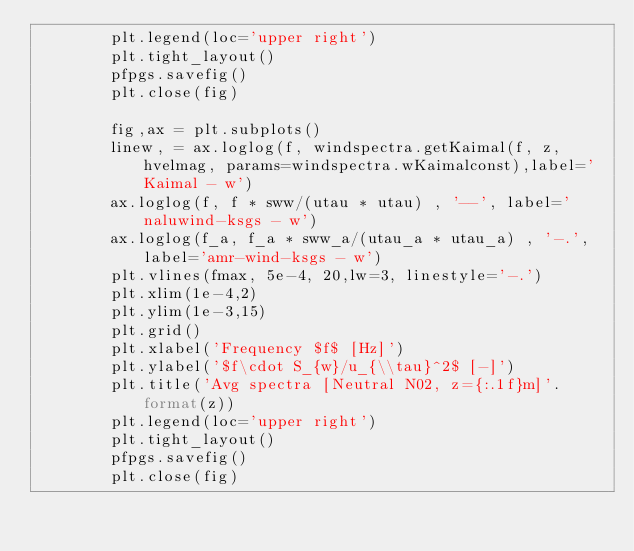<code> <loc_0><loc_0><loc_500><loc_500><_Python_>        plt.legend(loc='upper right')
        plt.tight_layout()
        pfpgs.savefig()
        plt.close(fig)
        
        fig,ax = plt.subplots()
        linew, = ax.loglog(f, windspectra.getKaimal(f, z, hvelmag, params=windspectra.wKaimalconst),label='Kaimal - w')
        ax.loglog(f, f * sww/(utau * utau) , '--', label='naluwind-ksgs - w')
        ax.loglog(f_a, f_a * sww_a/(utau_a * utau_a) , '-.', label='amr-wind-ksgs - w')
        plt.vlines(fmax, 5e-4, 20,lw=3, linestyle='-.')
        plt.xlim(1e-4,2)
        plt.ylim(1e-3,15)
        plt.grid()
        plt.xlabel('Frequency $f$ [Hz]')
        plt.ylabel('$f\cdot S_{w}/u_{\\tau}^2$ [-]')
        plt.title('Avg spectra [Neutral N02, z={:.1f}m]'.format(z))
        plt.legend(loc='upper right')
        plt.tight_layout()
        pfpgs.savefig()
        plt.close(fig)
        
</code> 